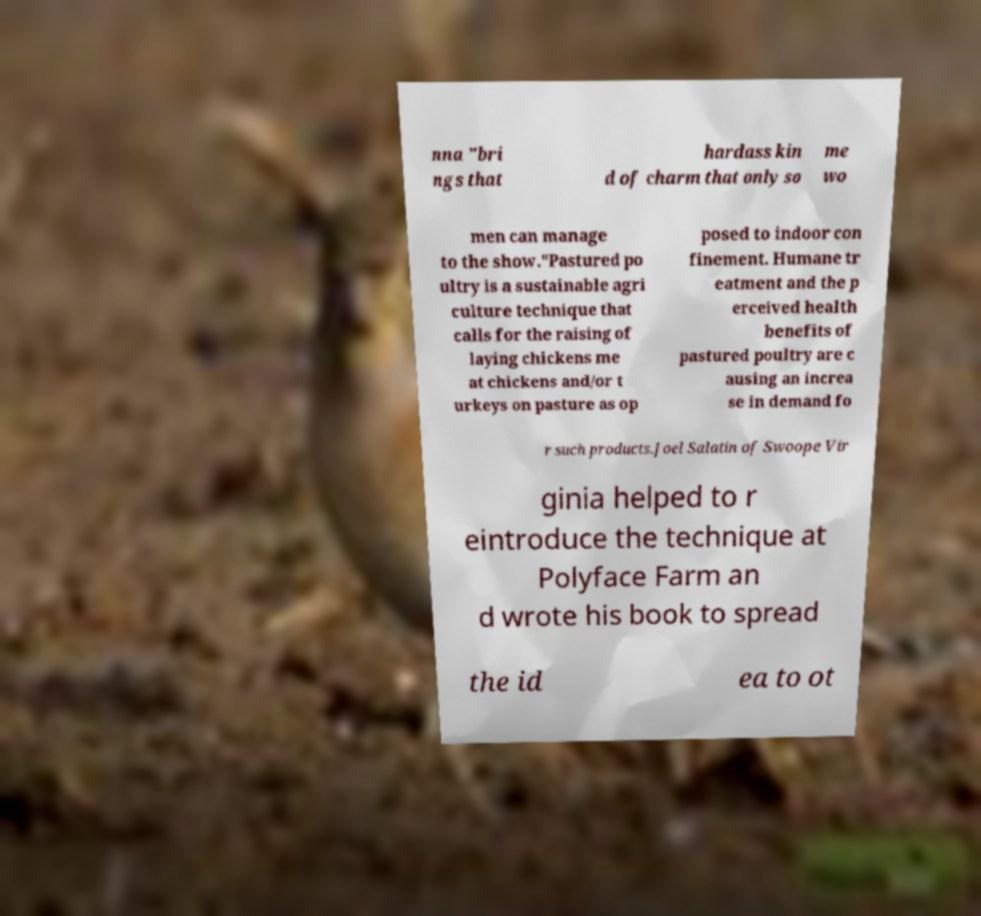For documentation purposes, I need the text within this image transcribed. Could you provide that? nna "bri ngs that hardass kin d of charm that only so me wo men can manage to the show."Pastured po ultry is a sustainable agri culture technique that calls for the raising of laying chickens me at chickens and/or t urkeys on pasture as op posed to indoor con finement. Humane tr eatment and the p erceived health benefits of pastured poultry are c ausing an increa se in demand fo r such products.Joel Salatin of Swoope Vir ginia helped to r eintroduce the technique at Polyface Farm an d wrote his book to spread the id ea to ot 